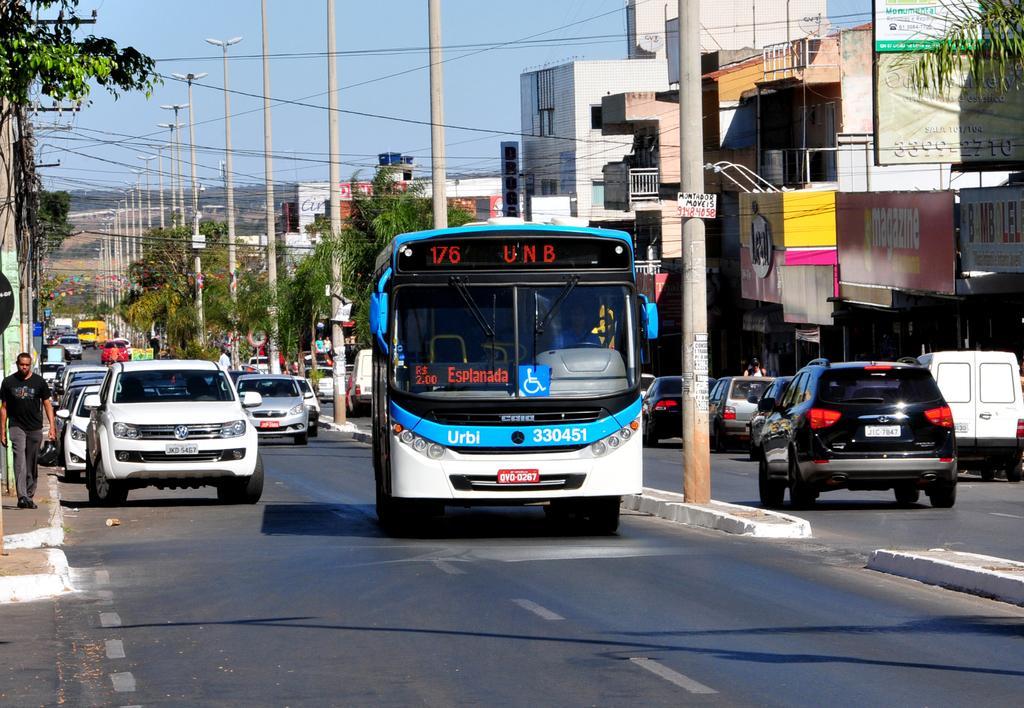How would you summarize this image in a sentence or two? In this picture we can observe some vehicles and a bus on the road. There are some poles and wires. We can observe some trees and buildings. In the background there is a sky. 